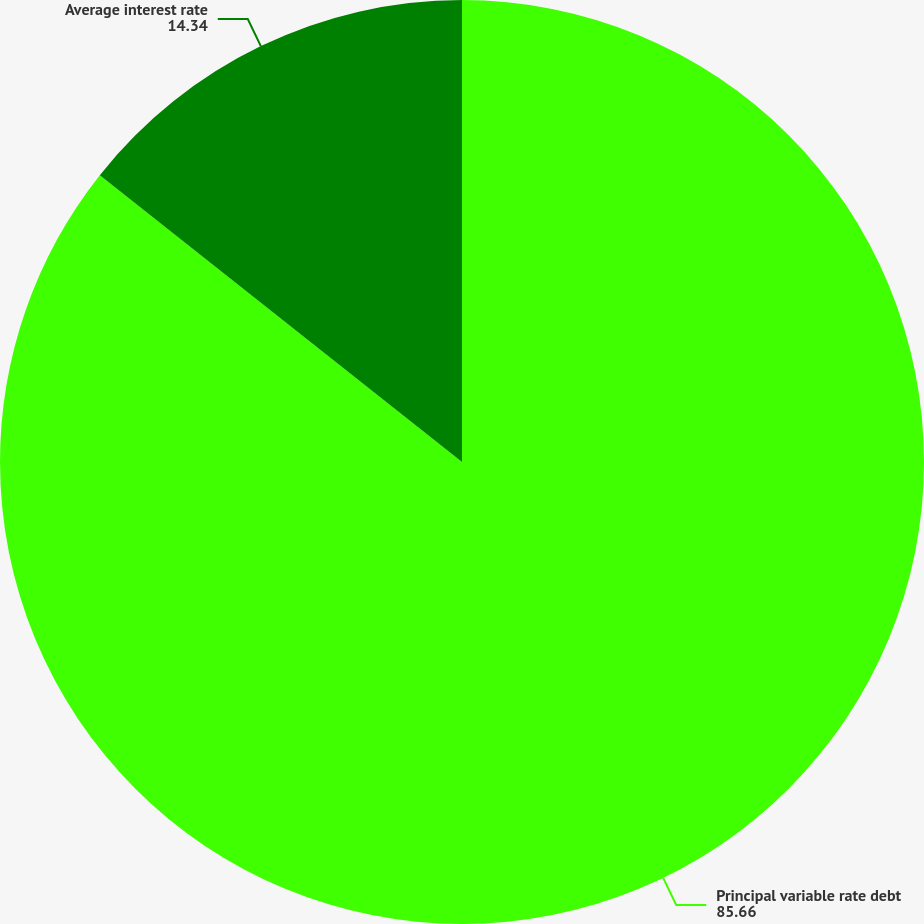<chart> <loc_0><loc_0><loc_500><loc_500><pie_chart><fcel>Principal variable rate debt<fcel>Average interest rate<nl><fcel>85.66%<fcel>14.34%<nl></chart> 